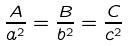Convert formula to latex. <formula><loc_0><loc_0><loc_500><loc_500>\frac { A } { a ^ { 2 } } = \frac { B } { b ^ { 2 } } = \frac { C } { c ^ { 2 } }</formula> 